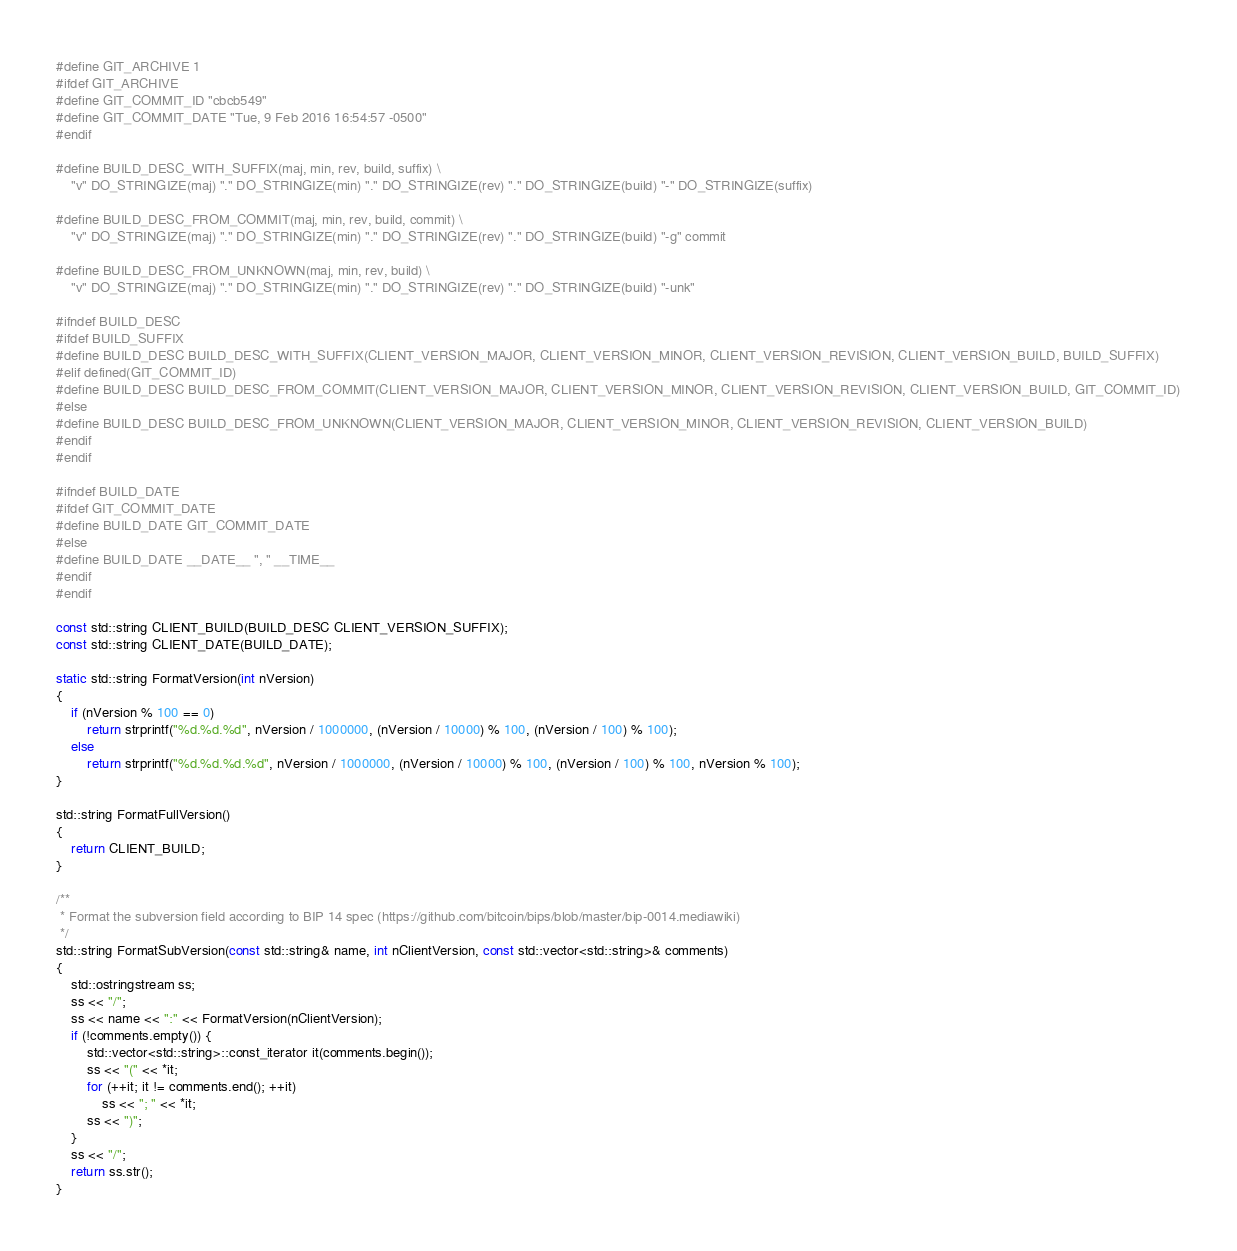<code> <loc_0><loc_0><loc_500><loc_500><_C++_>#define GIT_ARCHIVE 1
#ifdef GIT_ARCHIVE
#define GIT_COMMIT_ID "cbcb549"
#define GIT_COMMIT_DATE "Tue, 9 Feb 2016 16:54:57 -0500"
#endif

#define BUILD_DESC_WITH_SUFFIX(maj, min, rev, build, suffix) \
    "v" DO_STRINGIZE(maj) "." DO_STRINGIZE(min) "." DO_STRINGIZE(rev) "." DO_STRINGIZE(build) "-" DO_STRINGIZE(suffix)

#define BUILD_DESC_FROM_COMMIT(maj, min, rev, build, commit) \
    "v" DO_STRINGIZE(maj) "." DO_STRINGIZE(min) "." DO_STRINGIZE(rev) "." DO_STRINGIZE(build) "-g" commit

#define BUILD_DESC_FROM_UNKNOWN(maj, min, rev, build) \
    "v" DO_STRINGIZE(maj) "." DO_STRINGIZE(min) "." DO_STRINGIZE(rev) "." DO_STRINGIZE(build) "-unk"

#ifndef BUILD_DESC
#ifdef BUILD_SUFFIX
#define BUILD_DESC BUILD_DESC_WITH_SUFFIX(CLIENT_VERSION_MAJOR, CLIENT_VERSION_MINOR, CLIENT_VERSION_REVISION, CLIENT_VERSION_BUILD, BUILD_SUFFIX)
#elif defined(GIT_COMMIT_ID)
#define BUILD_DESC BUILD_DESC_FROM_COMMIT(CLIENT_VERSION_MAJOR, CLIENT_VERSION_MINOR, CLIENT_VERSION_REVISION, CLIENT_VERSION_BUILD, GIT_COMMIT_ID)
#else
#define BUILD_DESC BUILD_DESC_FROM_UNKNOWN(CLIENT_VERSION_MAJOR, CLIENT_VERSION_MINOR, CLIENT_VERSION_REVISION, CLIENT_VERSION_BUILD)
#endif
#endif

#ifndef BUILD_DATE
#ifdef GIT_COMMIT_DATE
#define BUILD_DATE GIT_COMMIT_DATE
#else
#define BUILD_DATE __DATE__ ", " __TIME__
#endif
#endif

const std::string CLIENT_BUILD(BUILD_DESC CLIENT_VERSION_SUFFIX);
const std::string CLIENT_DATE(BUILD_DATE);

static std::string FormatVersion(int nVersion)
{
    if (nVersion % 100 == 0)
        return strprintf("%d.%d.%d", nVersion / 1000000, (nVersion / 10000) % 100, (nVersion / 100) % 100);
    else
        return strprintf("%d.%d.%d.%d", nVersion / 1000000, (nVersion / 10000) % 100, (nVersion / 100) % 100, nVersion % 100);
}

std::string FormatFullVersion()
{
    return CLIENT_BUILD;
}

/** 
 * Format the subversion field according to BIP 14 spec (https://github.com/bitcoin/bips/blob/master/bip-0014.mediawiki) 
 */
std::string FormatSubVersion(const std::string& name, int nClientVersion, const std::vector<std::string>& comments)
{
    std::ostringstream ss;
    ss << "/";
    ss << name << ":" << FormatVersion(nClientVersion);
    if (!comments.empty()) {
        std::vector<std::string>::const_iterator it(comments.begin());
        ss << "(" << *it;
        for (++it; it != comments.end(); ++it)
            ss << "; " << *it;
        ss << ")";
    }
    ss << "/";
    return ss.str();
}
</code> 